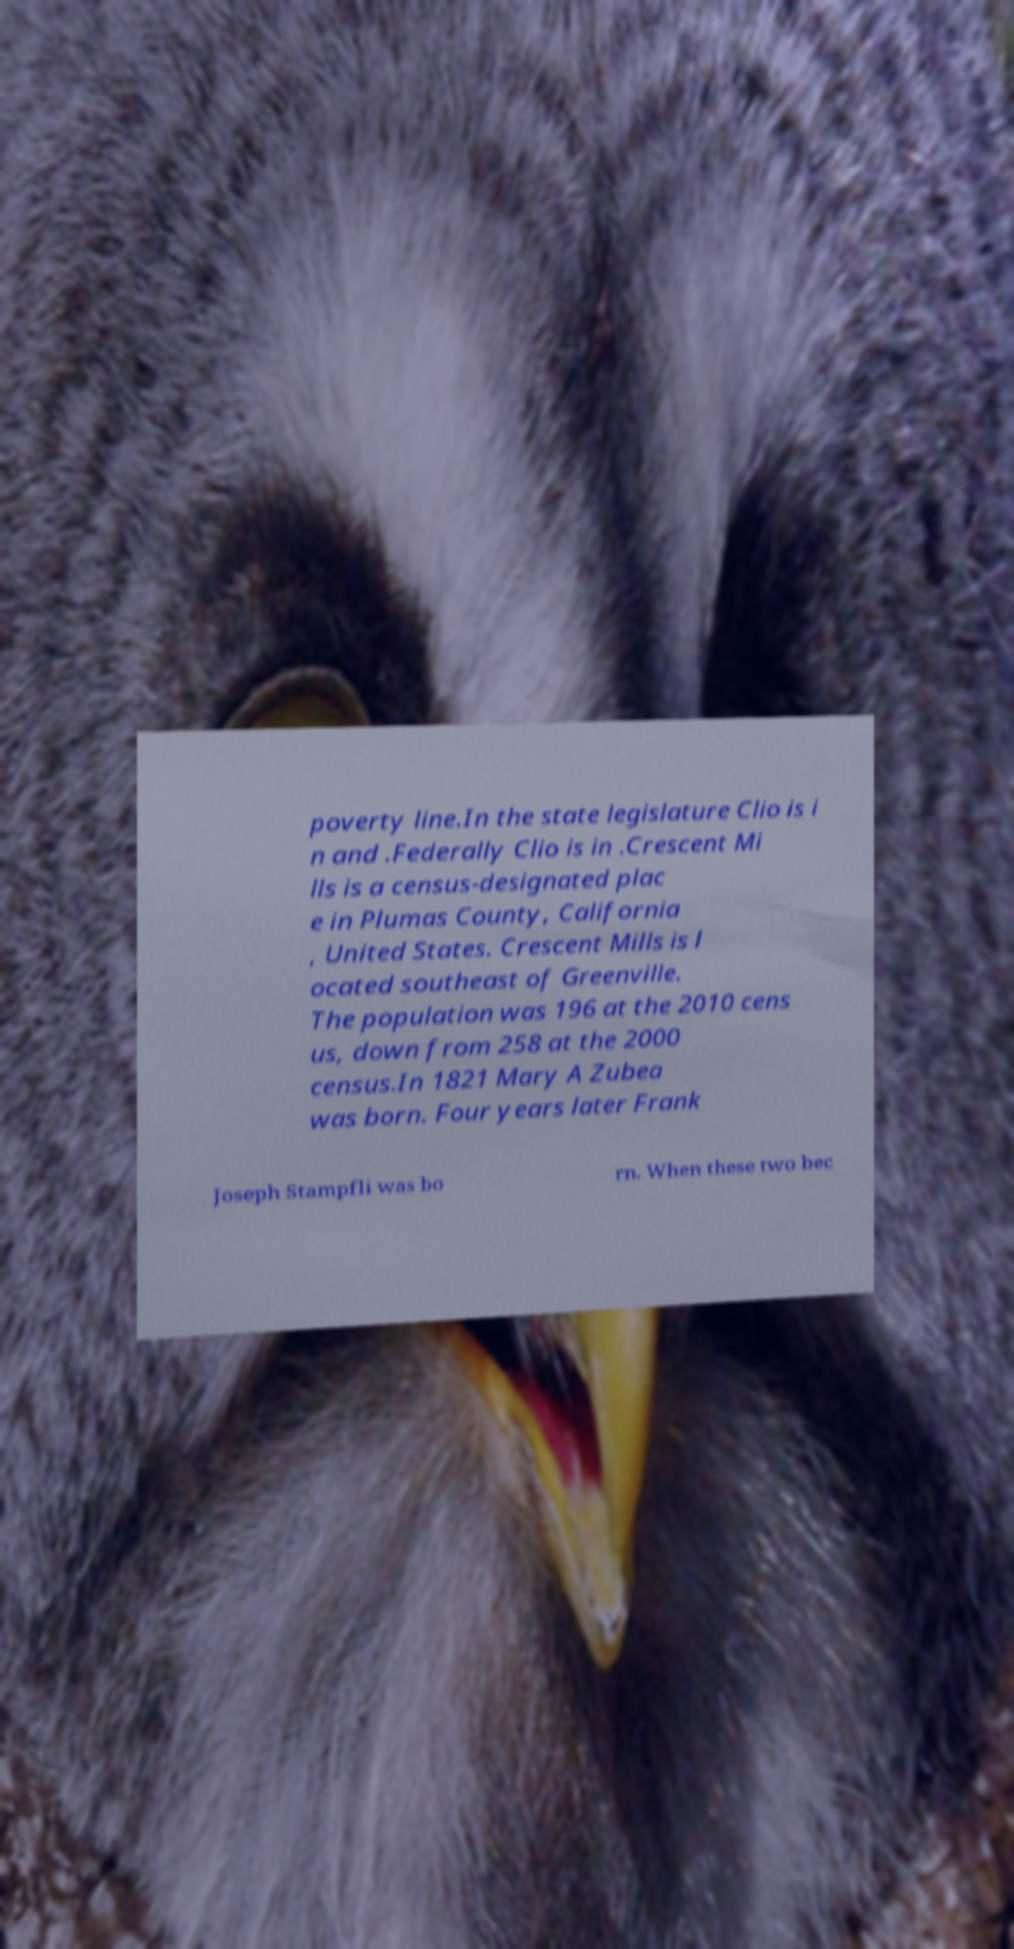Could you assist in decoding the text presented in this image and type it out clearly? poverty line.In the state legislature Clio is i n and .Federally Clio is in .Crescent Mi lls is a census-designated plac e in Plumas County, California , United States. Crescent Mills is l ocated southeast of Greenville. The population was 196 at the 2010 cens us, down from 258 at the 2000 census.In 1821 Mary A Zubea was born. Four years later Frank Joseph Stampfli was bo rn. When these two bec 